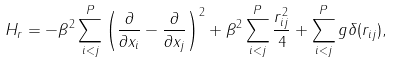<formula> <loc_0><loc_0><loc_500><loc_500>H _ { r } = - \beta ^ { 2 } \sum _ { i < j } ^ { P } \left ( \frac { \partial } { \partial x _ { i } } - \frac { \partial } { \partial x _ { j } } \right ) ^ { 2 } + \beta ^ { 2 } \sum _ { i < j } ^ { P } \frac { r _ { i j } ^ { 2 } } { 4 } + \sum _ { i < j } ^ { P } g \delta ( r _ { i j } ) ,</formula> 